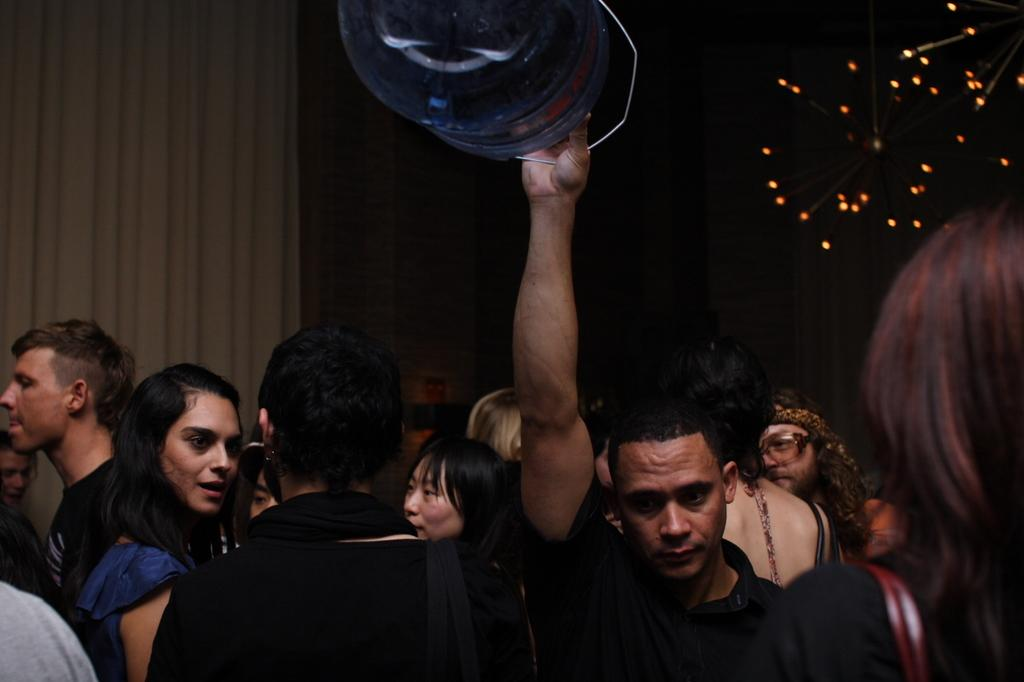How many people are in the image? There is a group of people in the image. What is one person holding in the image? One person is holding a water can. What can be seen in the background of the image? There is a curtain and lights visible in the background of the image. Is the queen playing a guitar in the image? There is no queen or guitar present in the image. 